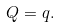<formula> <loc_0><loc_0><loc_500><loc_500>Q = q .</formula> 